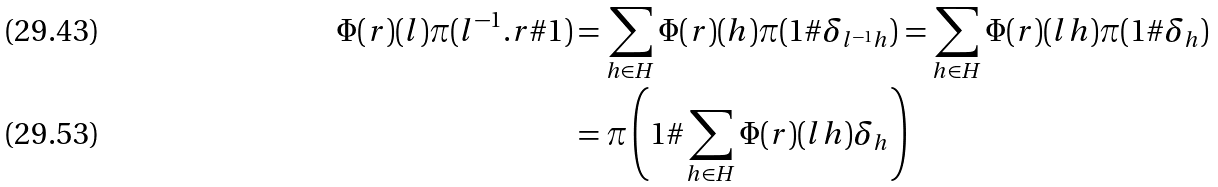Convert formula to latex. <formula><loc_0><loc_0><loc_500><loc_500>\Phi ( r ) ( l ) \pi ( l ^ { - 1 } . r \# 1 ) & = \sum _ { h \in H } \Phi ( r ) ( h ) \pi ( 1 \# \delta _ { l ^ { - 1 } h } ) = \sum _ { h \in H } \Phi ( r ) ( l h ) \pi ( 1 \# \delta _ { h } ) \\ & = \pi \left ( 1 \# \sum _ { h \in H } \Phi ( r ) ( l h ) \delta _ { h } \right )</formula> 